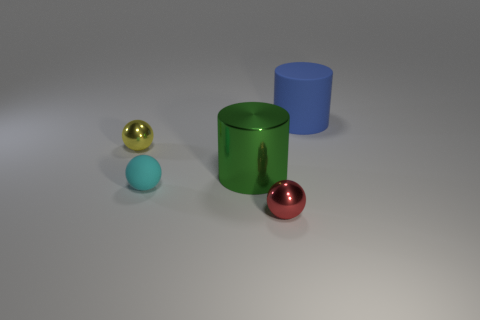There is a red metal thing that is the same size as the yellow metallic sphere; what is its shape?
Your response must be concise. Sphere. Does the sphere behind the small cyan ball have the same size as the rubber object that is in front of the rubber cylinder?
Keep it short and to the point. Yes. There is a tiny sphere that is the same material as the yellow object; what is its color?
Give a very brief answer. Red. Does the small red sphere that is in front of the cyan matte ball have the same material as the small sphere behind the green metallic cylinder?
Your response must be concise. Yes. Are there any green things of the same size as the rubber ball?
Offer a very short reply. No. There is a cylinder behind the tiny ball that is to the left of the small rubber ball; what size is it?
Keep it short and to the point. Large. What number of small metallic objects are the same color as the big matte thing?
Make the answer very short. 0. What is the shape of the tiny red thing in front of the tiny sphere behind the tiny cyan thing?
Your answer should be compact. Sphere. What number of yellow balls have the same material as the red object?
Provide a succinct answer. 1. What material is the ball that is behind the big shiny cylinder?
Make the answer very short. Metal. 